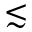<formula> <loc_0><loc_0><loc_500><loc_500>\lesssim</formula> 